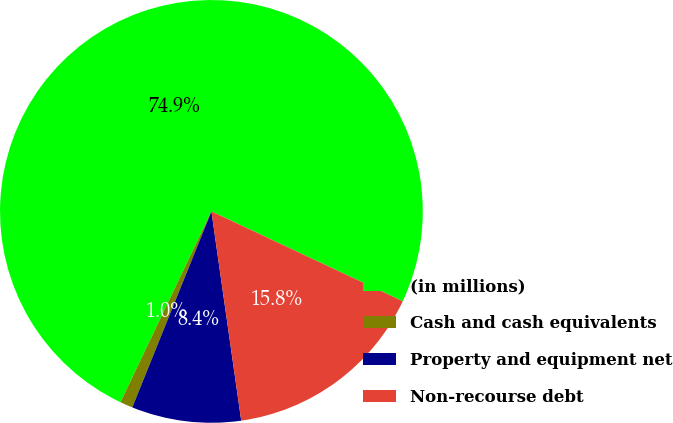Convert chart to OTSL. <chart><loc_0><loc_0><loc_500><loc_500><pie_chart><fcel>(in millions)<fcel>Cash and cash equivalents<fcel>Property and equipment net<fcel>Non-recourse debt<nl><fcel>74.91%<fcel>0.97%<fcel>8.36%<fcel>15.76%<nl></chart> 